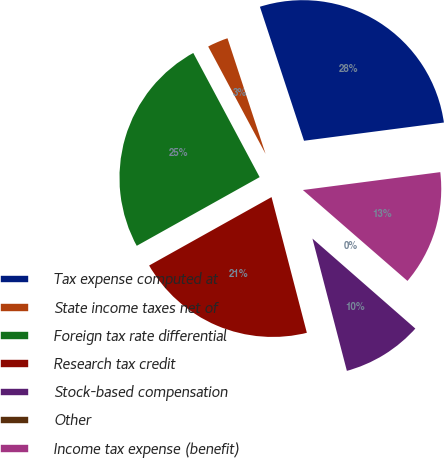Convert chart to OTSL. <chart><loc_0><loc_0><loc_500><loc_500><pie_chart><fcel>Tax expense computed at<fcel>State income taxes net of<fcel>Foreign tax rate differential<fcel>Research tax credit<fcel>Stock-based compensation<fcel>Other<fcel>Income tax expense (benefit)<nl><fcel>28.0%<fcel>2.75%<fcel>25.3%<fcel>20.94%<fcel>9.51%<fcel>0.05%<fcel>13.45%<nl></chart> 